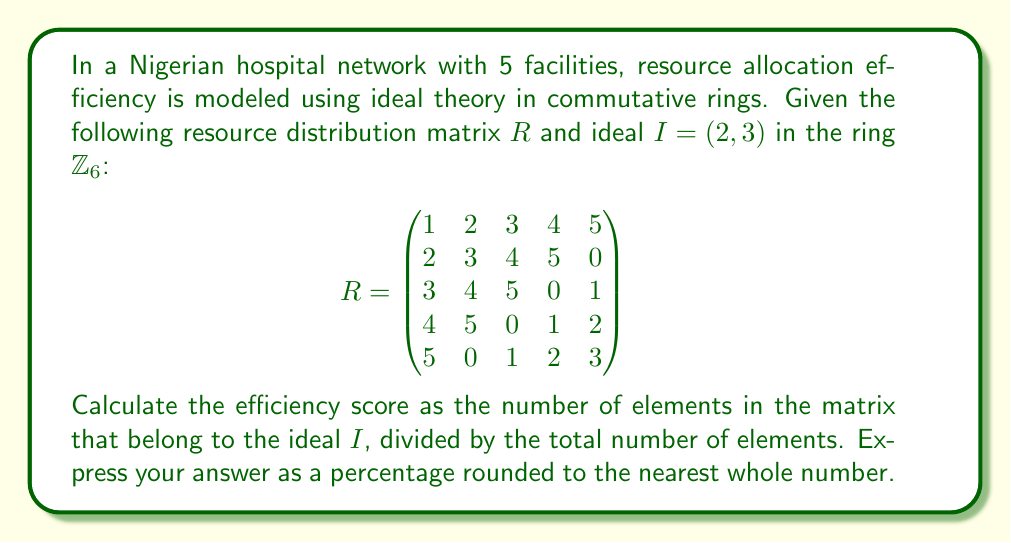Can you solve this math problem? To solve this problem, we'll follow these steps:

1) First, we need to understand what it means for an element to belong to the ideal $I = (2, 3)$ in $\mathbb{Z}_6$:
   An element $a \in \mathbb{Z}_6$ belongs to $I$ if $a = 2x + 3y$ (mod 6) for some $x, y \in \mathbb{Z}_6$.

2) The elements of $I$ are:
   $I = \{0, 2, 3, 4\}$ in $\mathbb{Z}_6$

3) Now, we count how many elements in the matrix $R$ belong to $I$:
   
   $$\begin{pmatrix}
   \color{red}{1} & \color{blue}{2} & \color{blue}{3} & \color{blue}{4} & \color{red}{5} \\
   \color{blue}{2} & \color{blue}{3} & \color{blue}{4} & \color{red}{5} & \color{blue}{0} \\
   \color{blue}{3} & \color{blue}{4} & \color{red}{5} & \color{blue}{0} & \color{red}{1} \\
   \color{blue}{4} & \color{red}{5} & \color{blue}{0} & \color{red}{1} & \color{blue}{2} \\
   \color{red}{5} & \color{blue}{0} & \color{red}{1} & \color{blue}{2} & \color{blue}{3}
   \end{pmatrix}$$

   Blue elements belong to $I$, red elements do not.

4) Count the blue elements: 17

5) Total number of elements in the matrix: 5 × 5 = 25

6) Efficiency score = (Number of elements in $I$ / Total number of elements) × 100%
                    = (17 / 25) × 100% ≈ 68%
Answer: 68% 